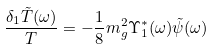Convert formula to latex. <formula><loc_0><loc_0><loc_500><loc_500>\frac { \delta _ { 1 } \tilde { T } ( \omega ) } { T } = - \frac { 1 } { 8 } m _ { g } ^ { 2 } \Upsilon _ { 1 } ^ { * } ( \omega ) \tilde { \psi } ( \omega )</formula> 